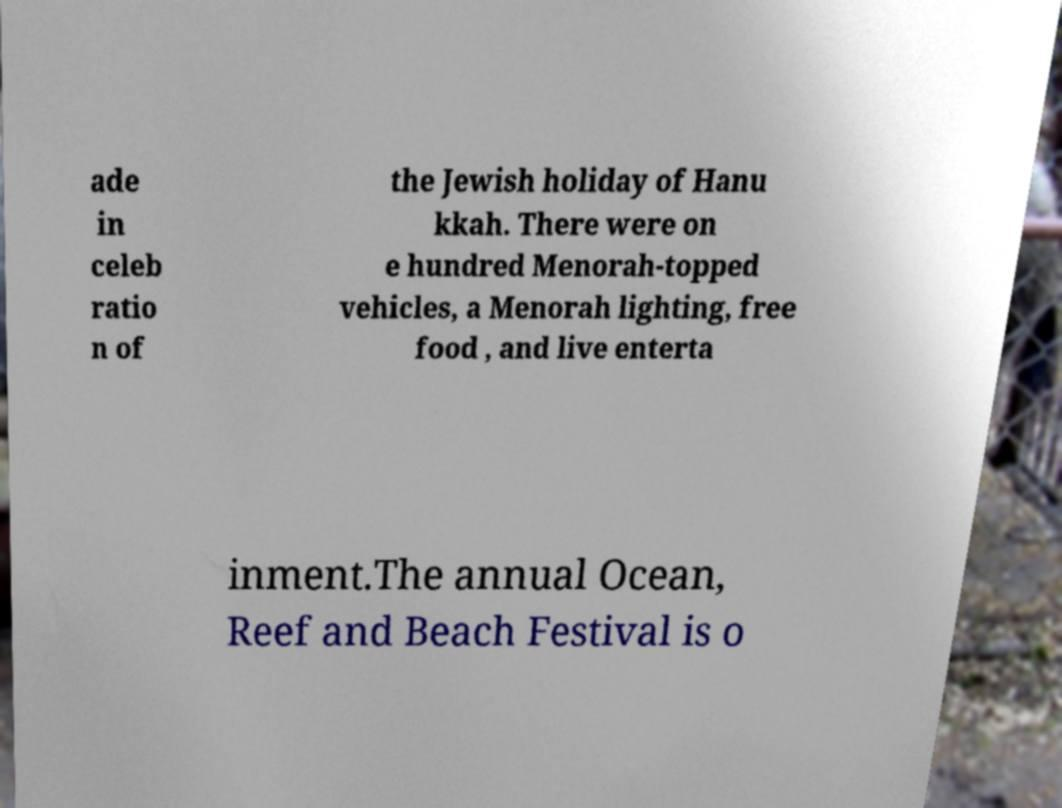There's text embedded in this image that I need extracted. Can you transcribe it verbatim? ade in celeb ratio n of the Jewish holiday of Hanu kkah. There were on e hundred Menorah-topped vehicles, a Menorah lighting, free food , and live enterta inment.The annual Ocean, Reef and Beach Festival is o 